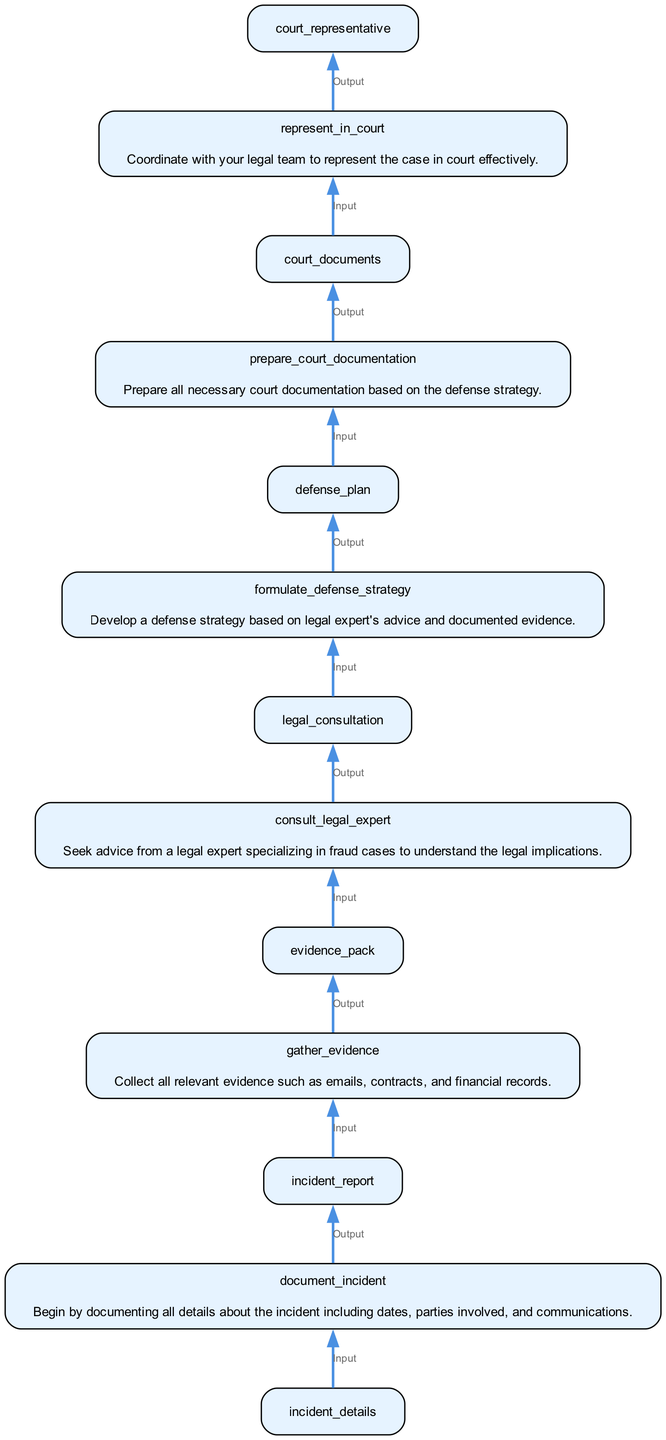What is the first function in the flowchart? The first function in the flowchart is located at the bottom and it is "document_incident," where details about the incident are documented.
Answer: document_incident How many nodes are in the diagram? By counting each of the functions or steps stated in the diagram, we find there are six distinct functions or nodes in total.
Answer: 6 What is the output of the function "gather_evidence"? The output of "gather_evidence," which collects relevant evidence, is "evidence_pack" as indicated by the diagram.
Answer: evidence_pack What input does the function "prepare_court_documentation" require? The function "prepare_court_documentation" requires the input from the previous function's output, which is "defense_plan."
Answer: defense_plan Which function directly follows "consult_legal_expert"? The function that directly follows "consult_legal_expert" is "formulate_defense_strategy", which indicates the progression after consulting with a legal expert.
Answer: formulate_defense_strategy What would happen to the case if "represent_in_court" is bypassed? If "represent_in_court" is bypassed, there would be no formal representation for the case in court, which could negatively impact the outcome.
Answer: No representation How many edges connect to the function "formulate_defense_strategy"? "formulate_defense_strategy" has one incoming edge from "consult_legal_expert" and one outgoing edge to "prepare_court_documentation," totaling two edges.
Answer: 2 Which function is the last step in the legal defense strategy? The last step in the process, as indicated by the flowchart, is the function "represent_in_court," which signifies the final action in the legal strategy.
Answer: represent_in_court What is the purpose of the "document_incident" function? The function "document_incident" serves the purpose of documenting all relevant details surrounding the incident, making it foundational to the defense strategy.
Answer: Documenting details 